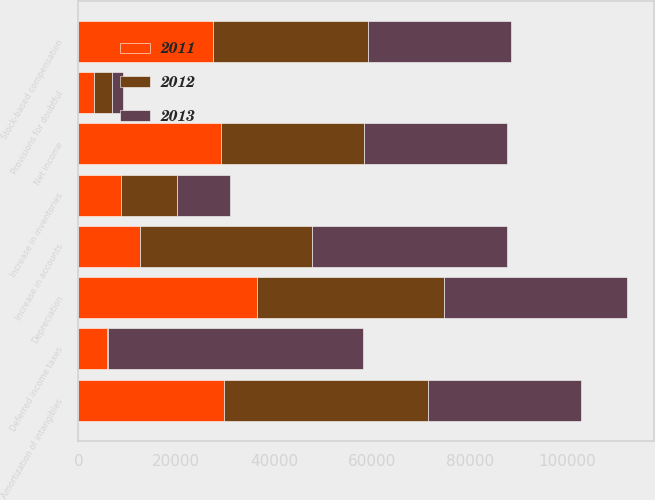Convert chart. <chart><loc_0><loc_0><loc_500><loc_500><stacked_bar_chart><ecel><fcel>Net income<fcel>Provisions for doubtful<fcel>Stock-based compensation<fcel>Deferred income taxes<fcel>Depreciation<fcel>Amortization of intangibles<fcel>Increase in accounts<fcel>Increase in inventories<nl><fcel>2012<fcel>29183<fcel>3656<fcel>31708<fcel>169<fcel>38165<fcel>41530<fcel>35233<fcel>11389<nl><fcel>2013<fcel>29183<fcel>2256<fcel>29183<fcel>52219<fcel>37422<fcel>31409<fcel>39836<fcel>10930<nl><fcel>2011<fcel>29183<fcel>3265<fcel>27579<fcel>5824<fcel>36531<fcel>29856<fcel>12528<fcel>8707<nl></chart> 